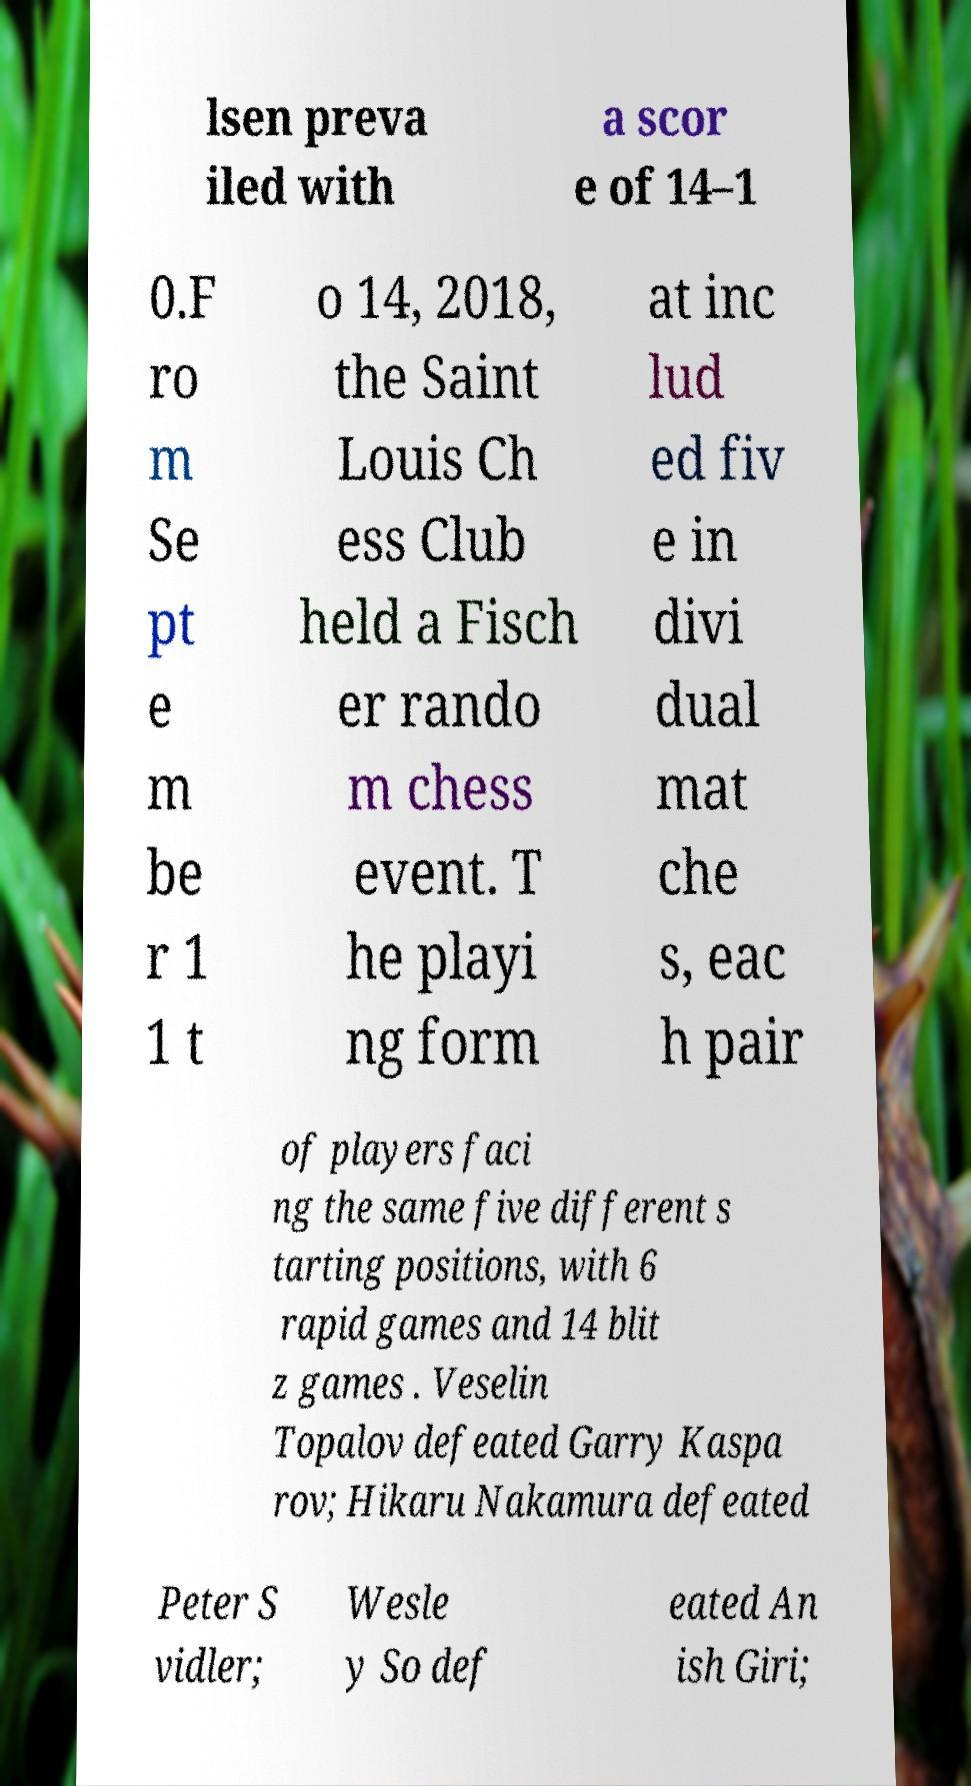For documentation purposes, I need the text within this image transcribed. Could you provide that? lsen preva iled with a scor e of 14–1 0.F ro m Se pt e m be r 1 1 t o 14, 2018, the Saint Louis Ch ess Club held a Fisch er rando m chess event. T he playi ng form at inc lud ed fiv e in divi dual mat che s, eac h pair of players faci ng the same five different s tarting positions, with 6 rapid games and 14 blit z games . Veselin Topalov defeated Garry Kaspa rov; Hikaru Nakamura defeated Peter S vidler; Wesle y So def eated An ish Giri; 